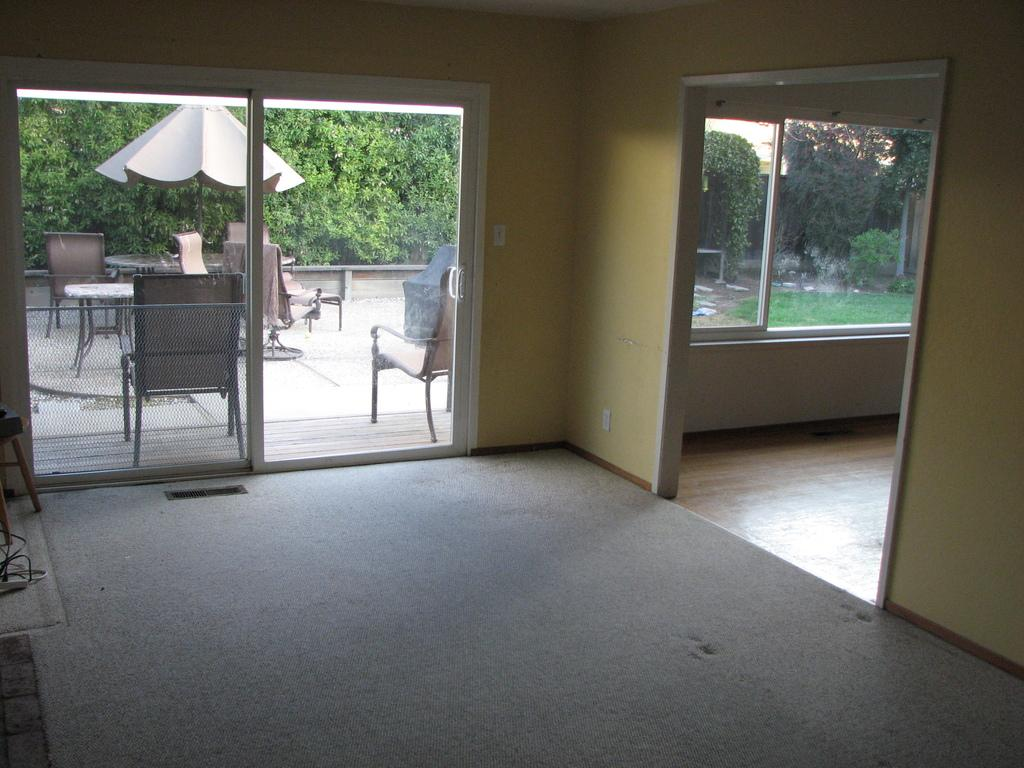What type of room is shown in the image? The image is an inside view of a room. What feature of the room can be seen in the image? There is a glass door in the room. What can be seen through the glass door? Wooden chairs and tables are visible through the glass door. What is visible in the background of the image? There are trees in the background of the image. What effect does the company have on the trees in the image? There is no company mentioned in the image, and therefore no effect on the trees can be determined. 